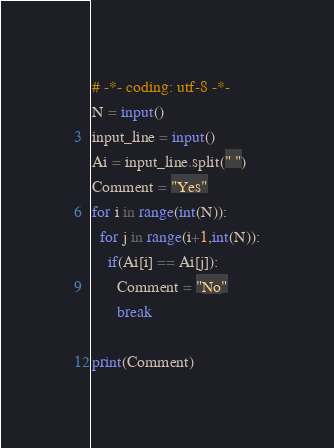<code> <loc_0><loc_0><loc_500><loc_500><_Python_># -*- coding: utf-8 -*-
N = input()
input_line = input()
Ai = input_line.split(" ")
Comment = "Yes"
for i in range(int(N)):
  for j in range(i+1,int(N)):
    if(Ai[i] == Ai[j]):
      Comment = "No"
      break
      
print(Comment)</code> 